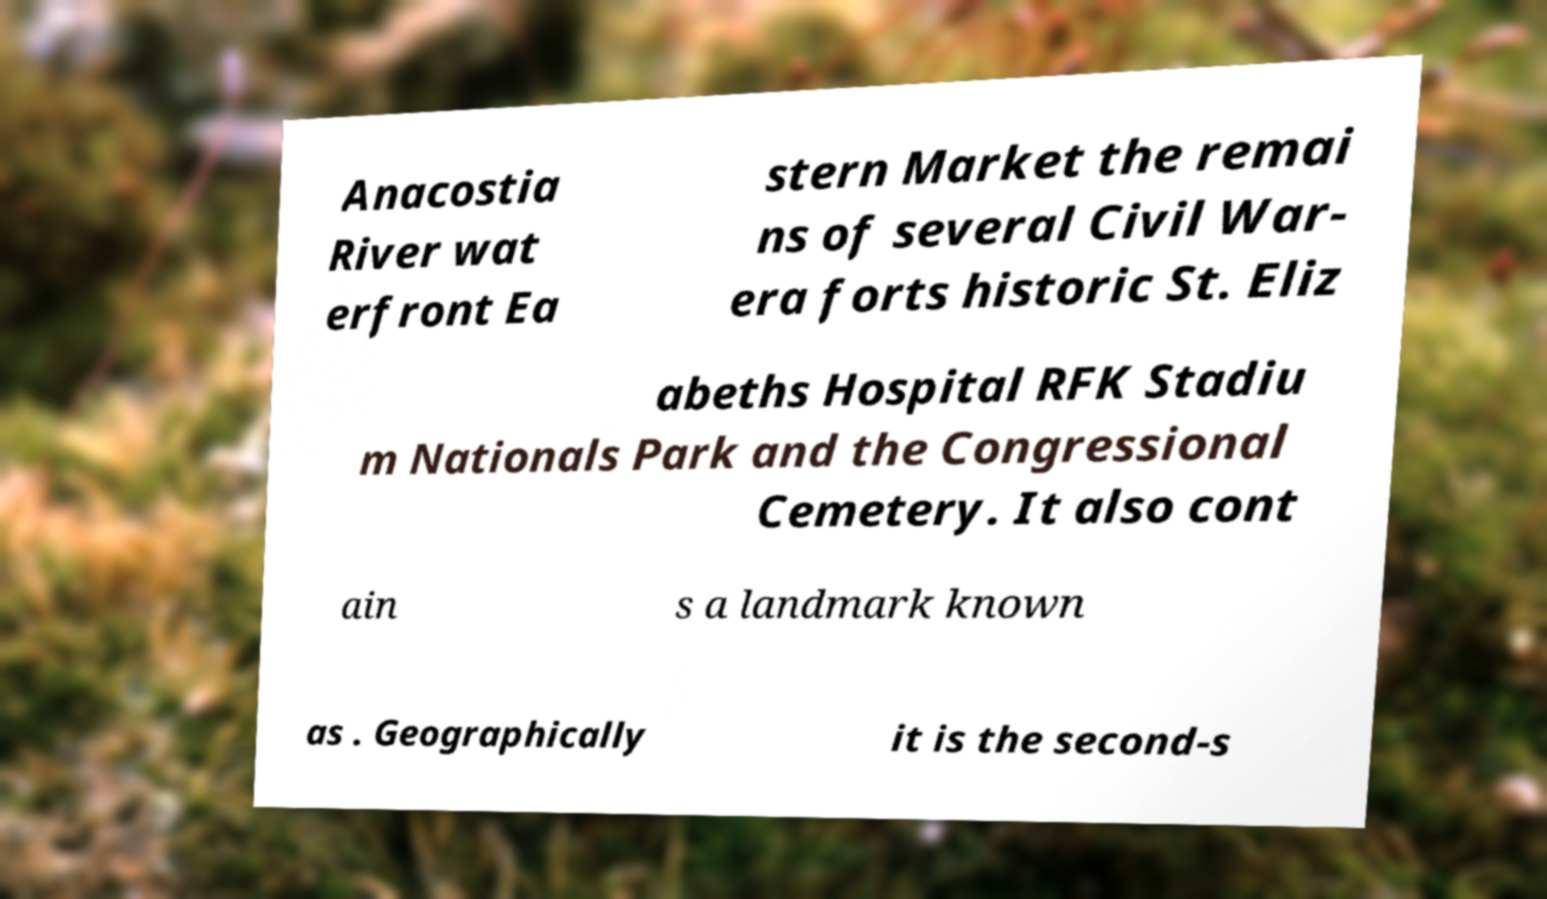What messages or text are displayed in this image? I need them in a readable, typed format. Anacostia River wat erfront Ea stern Market the remai ns of several Civil War- era forts historic St. Eliz abeths Hospital RFK Stadiu m Nationals Park and the Congressional Cemetery. It also cont ain s a landmark known as . Geographically it is the second-s 